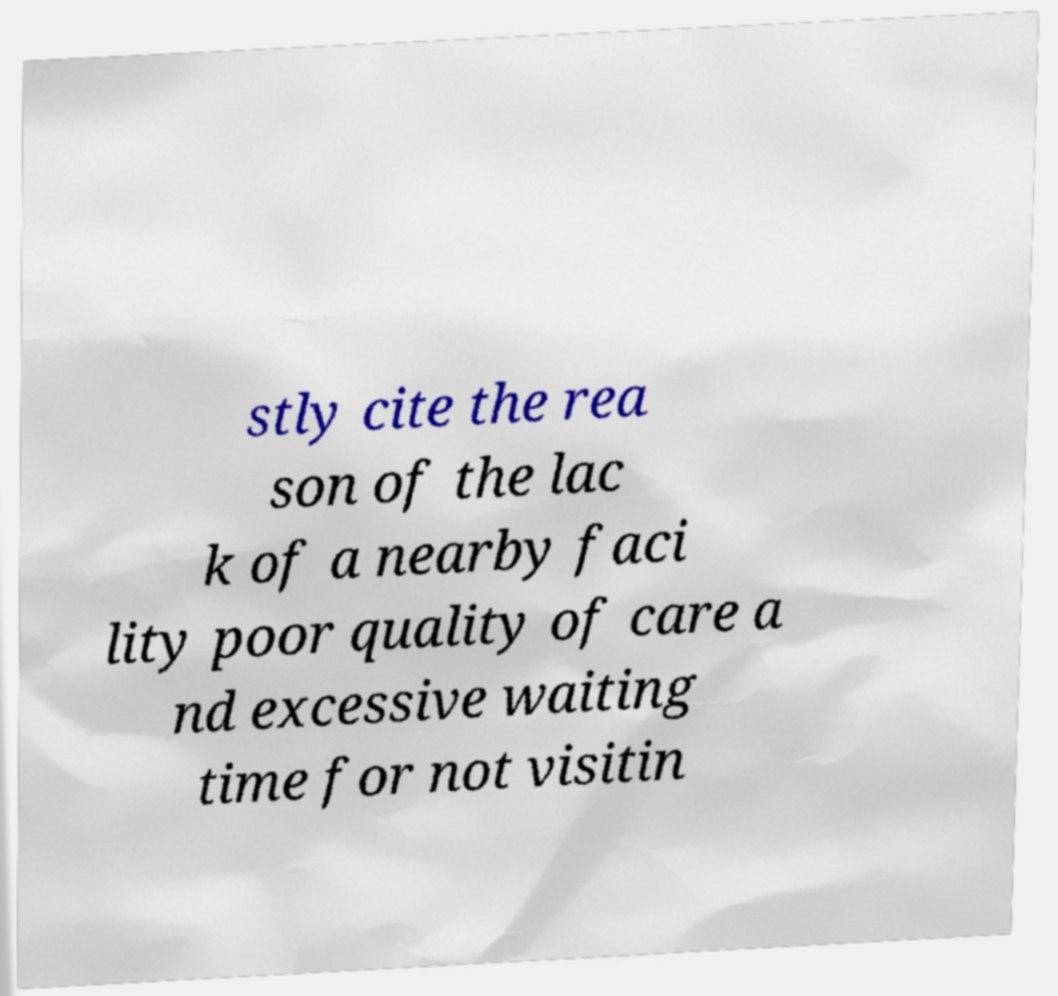Could you assist in decoding the text presented in this image and type it out clearly? stly cite the rea son of the lac k of a nearby faci lity poor quality of care a nd excessive waiting time for not visitin 